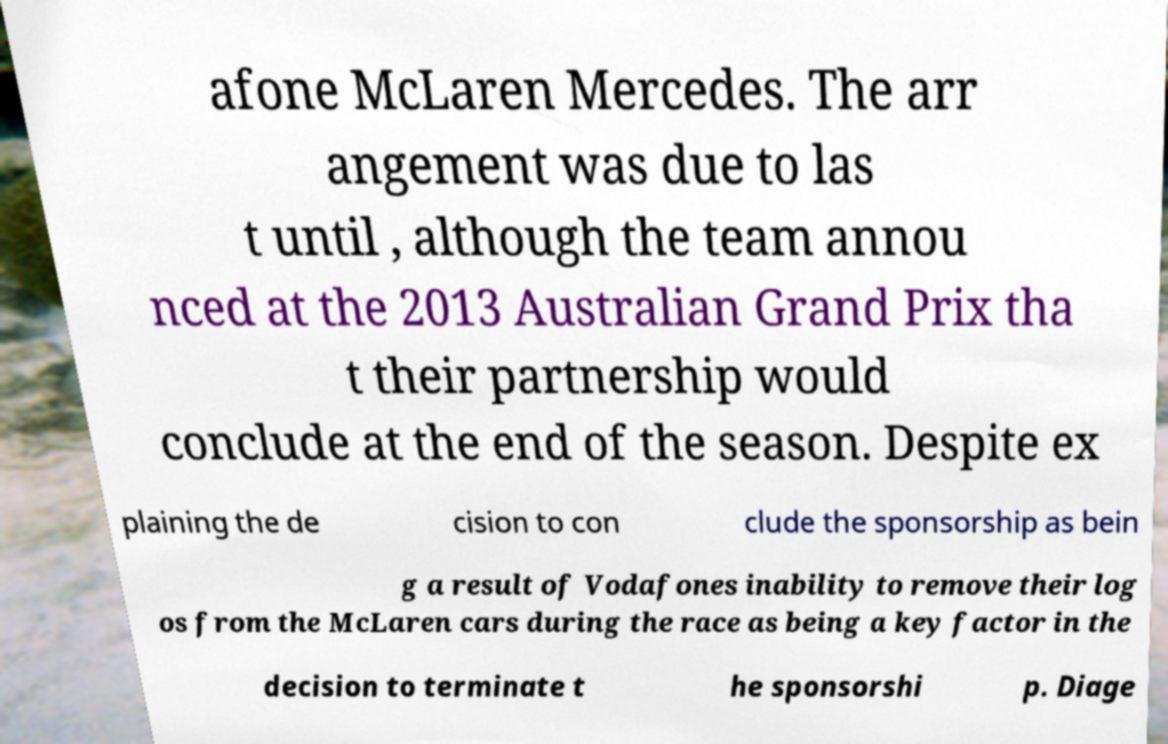There's text embedded in this image that I need extracted. Can you transcribe it verbatim? afone McLaren Mercedes. The arr angement was due to las t until , although the team annou nced at the 2013 Australian Grand Prix tha t their partnership would conclude at the end of the season. Despite ex plaining the de cision to con clude the sponsorship as bein g a result of Vodafones inability to remove their log os from the McLaren cars during the race as being a key factor in the decision to terminate t he sponsorshi p. Diage 